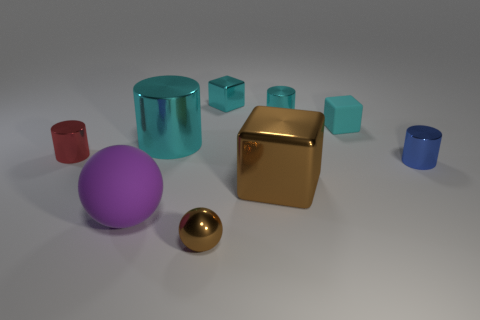What materials do the objects appear to be made of? The objects in the image seem to display properties of different materials. The shiny ones likely represent metallic surfaces, reflecting light in a way that's characteristic of metals. The matte objects, on the other hand, scatter light more uniformly and therefore appear to be made of a non-metallic, more diffuse material, possibly plastic or ceramic. 